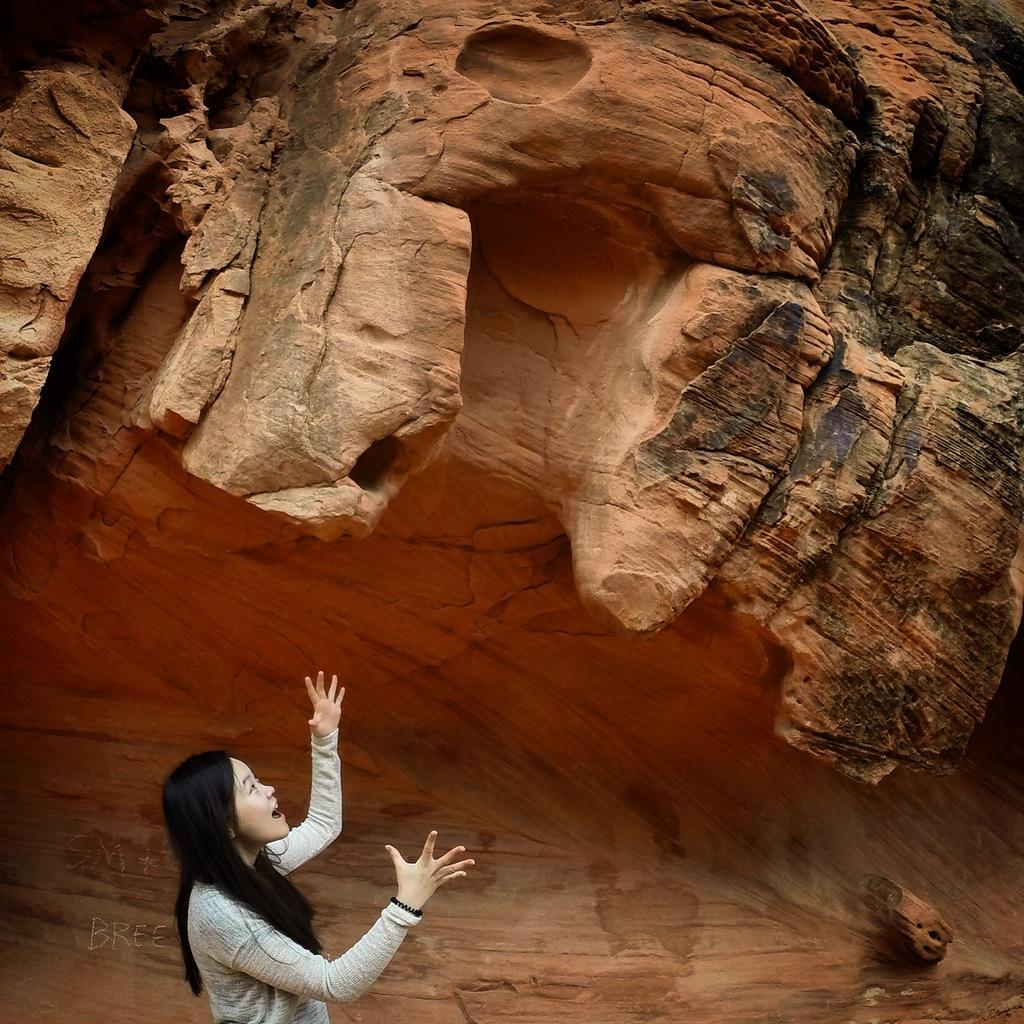Who is present in the image? There is a girl in the image. What can be seen in the background of the image? There is a canyon in the background of the image. Is there any text or wording in the image? Yes, there is a word on the image. What type of test can be seen being conducted in the image? There is no test being conducted in the image; it features a girl and a canyon in the background. Can you describe the basin or container holding water in the image? There is no basin or container holding water present in the image. 